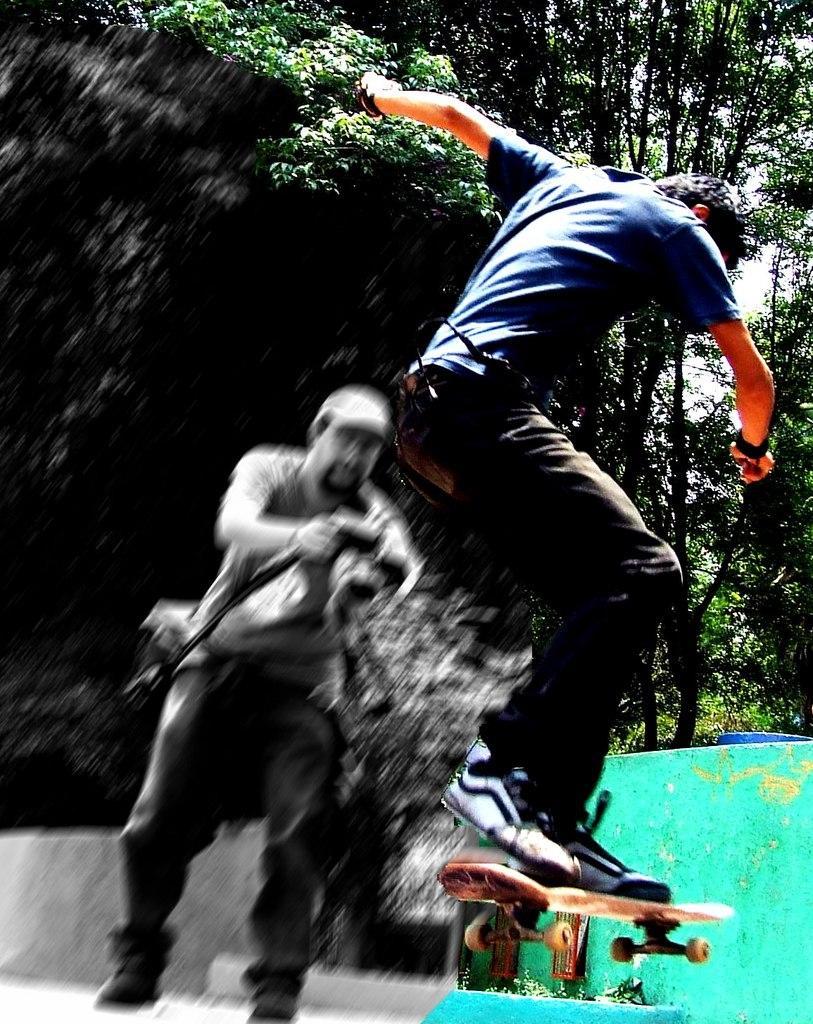Can you describe this image briefly? In this image, we can see two people. Here a person is holding a camera. Right side of the image, a person is on the air with skateboard. Background we can see trees. 